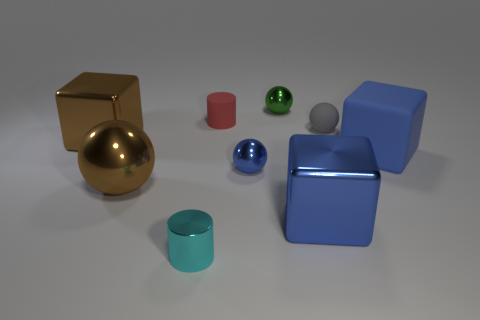Could you describe the lighting of the scene? The lighting of the scene is soft and diffuse, with a slight emphasis casting light from the upper right corner, as indicated by the shadows extending towards the lower left. The gentle shadows and light suggest an indoor environment, possibly under even overhead lighting. 